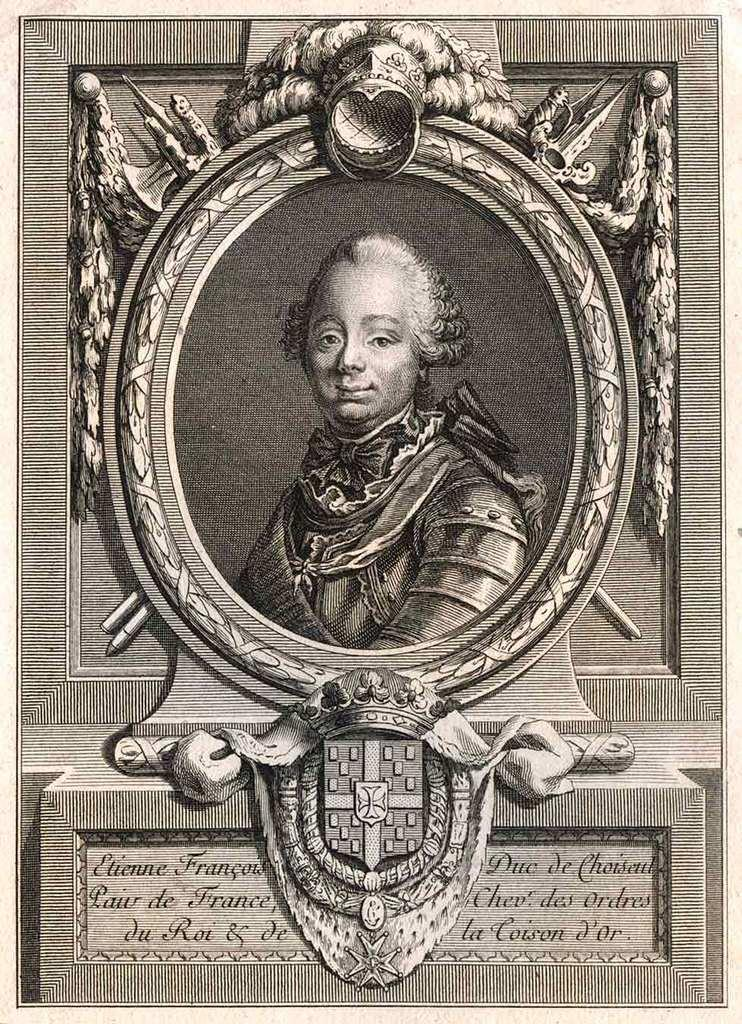<image>
Provide a brief description of the given image. Framed picture of a man's face and the word "Etienne" under it. 